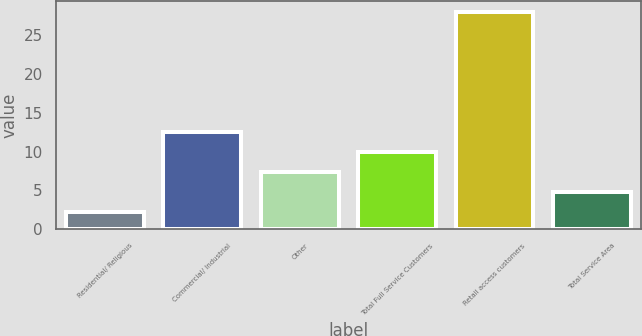Convert chart to OTSL. <chart><loc_0><loc_0><loc_500><loc_500><bar_chart><fcel>Residential/ Religious<fcel>Commercial/ Industrial<fcel>Other<fcel>Total Full Service Customers<fcel>Retail access customers<fcel>Total Service Area<nl><fcel>2.3<fcel>12.54<fcel>7.42<fcel>9.98<fcel>27.9<fcel>4.86<nl></chart> 